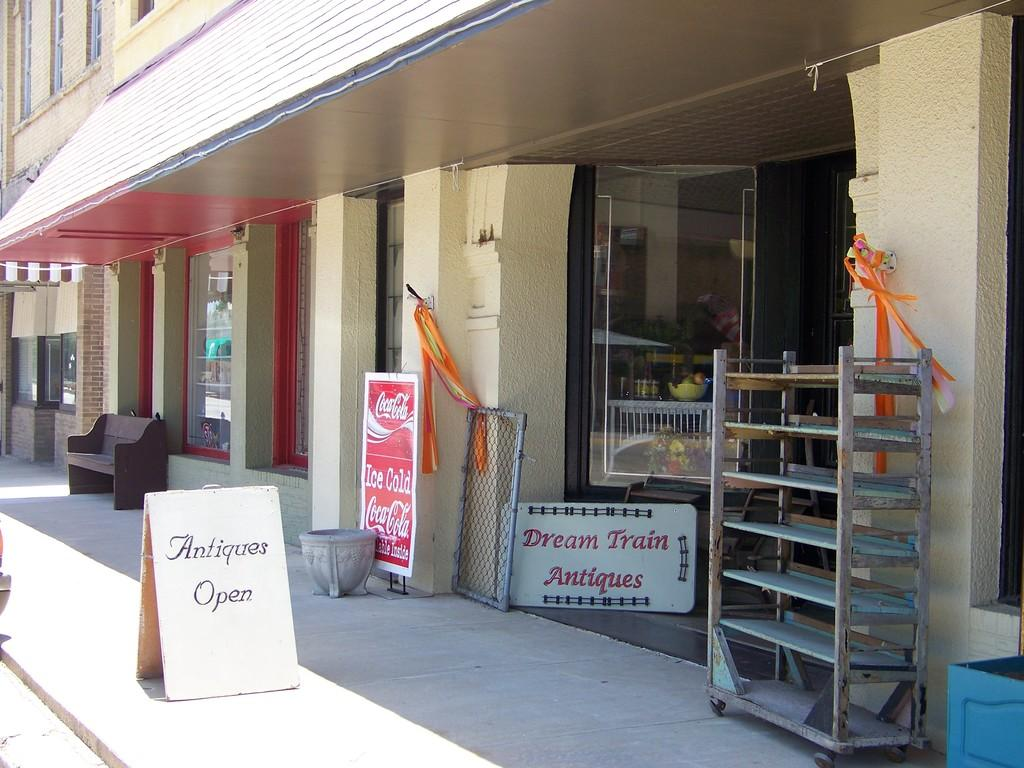What type of structures are present in the image? There are buildings in the image. What other objects can be seen in the image? There are boards, a bench, and a rack in the image. Where is the bench located in relation to the building? The bench is in front of the building. What is the purpose of the rack in the image? The rack is used to hold objects, as there are objects visible on it. What type of drug is being advertised on the company's sign in the image? There is no sign or company mentioned in the image, and no drug is being advertised. 